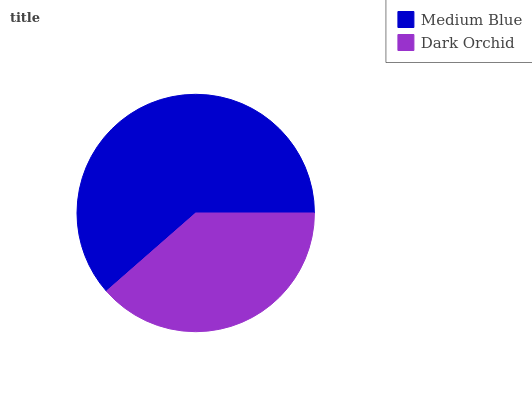Is Dark Orchid the minimum?
Answer yes or no. Yes. Is Medium Blue the maximum?
Answer yes or no. Yes. Is Dark Orchid the maximum?
Answer yes or no. No. Is Medium Blue greater than Dark Orchid?
Answer yes or no. Yes. Is Dark Orchid less than Medium Blue?
Answer yes or no. Yes. Is Dark Orchid greater than Medium Blue?
Answer yes or no. No. Is Medium Blue less than Dark Orchid?
Answer yes or no. No. Is Medium Blue the high median?
Answer yes or no. Yes. Is Dark Orchid the low median?
Answer yes or no. Yes. Is Dark Orchid the high median?
Answer yes or no. No. Is Medium Blue the low median?
Answer yes or no. No. 